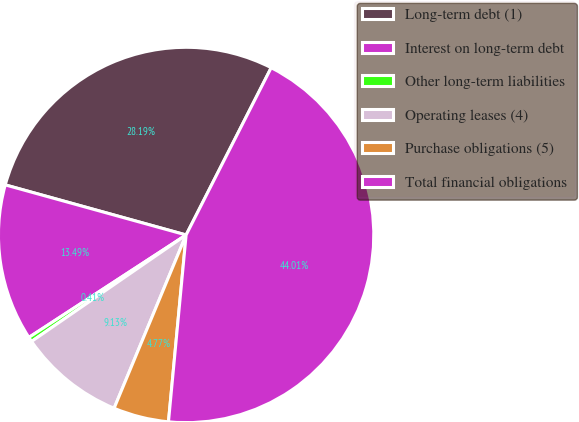<chart> <loc_0><loc_0><loc_500><loc_500><pie_chart><fcel>Long-term debt (1)<fcel>Interest on long-term debt<fcel>Other long-term liabilities<fcel>Operating leases (4)<fcel>Purchase obligations (5)<fcel>Total financial obligations<nl><fcel>28.19%<fcel>13.49%<fcel>0.41%<fcel>9.13%<fcel>4.77%<fcel>44.01%<nl></chart> 